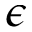Convert formula to latex. <formula><loc_0><loc_0><loc_500><loc_500>\epsilon</formula> 